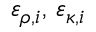<formula> <loc_0><loc_0><loc_500><loc_500>\varepsilon _ { \rho , i } , \, \varepsilon _ { \kappa , i }</formula> 